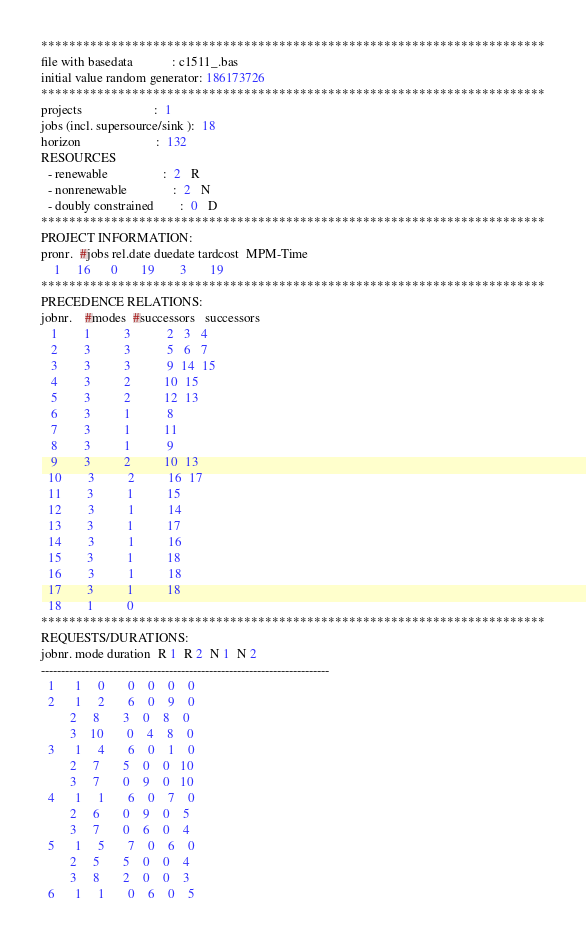<code> <loc_0><loc_0><loc_500><loc_500><_ObjectiveC_>************************************************************************
file with basedata            : c1511_.bas
initial value random generator: 186173726
************************************************************************
projects                      :  1
jobs (incl. supersource/sink ):  18
horizon                       :  132
RESOURCES
  - renewable                 :  2   R
  - nonrenewable              :  2   N
  - doubly constrained        :  0   D
************************************************************************
PROJECT INFORMATION:
pronr.  #jobs rel.date duedate tardcost  MPM-Time
    1     16      0       19        3       19
************************************************************************
PRECEDENCE RELATIONS:
jobnr.    #modes  #successors   successors
   1        1          3           2   3   4
   2        3          3           5   6   7
   3        3          3           9  14  15
   4        3          2          10  15
   5        3          2          12  13
   6        3          1           8
   7        3          1          11
   8        3          1           9
   9        3          2          10  13
  10        3          2          16  17
  11        3          1          15
  12        3          1          14
  13        3          1          17
  14        3          1          16
  15        3          1          18
  16        3          1          18
  17        3          1          18
  18        1          0        
************************************************************************
REQUESTS/DURATIONS:
jobnr. mode duration  R 1  R 2  N 1  N 2
------------------------------------------------------------------------
  1      1     0       0    0    0    0
  2      1     2       6    0    9    0
         2     8       3    0    8    0
         3    10       0    4    8    0
  3      1     4       6    0    1    0
         2     7       5    0    0   10
         3     7       0    9    0   10
  4      1     1       6    0    7    0
         2     6       0    9    0    5
         3     7       0    6    0    4
  5      1     5       7    0    6    0
         2     5       5    0    0    4
         3     8       2    0    0    3
  6      1     1       0    6    0    5</code> 